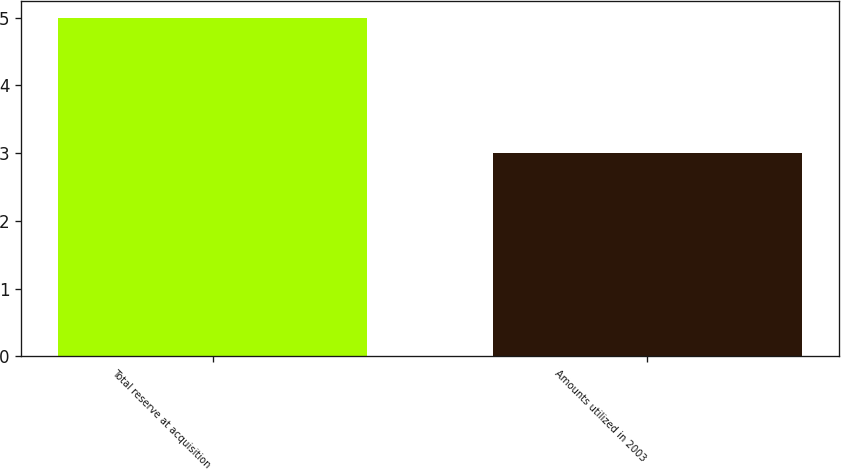Convert chart. <chart><loc_0><loc_0><loc_500><loc_500><bar_chart><fcel>Total reserve at acquisition<fcel>Amounts utilized in 2003<nl><fcel>5<fcel>3<nl></chart> 